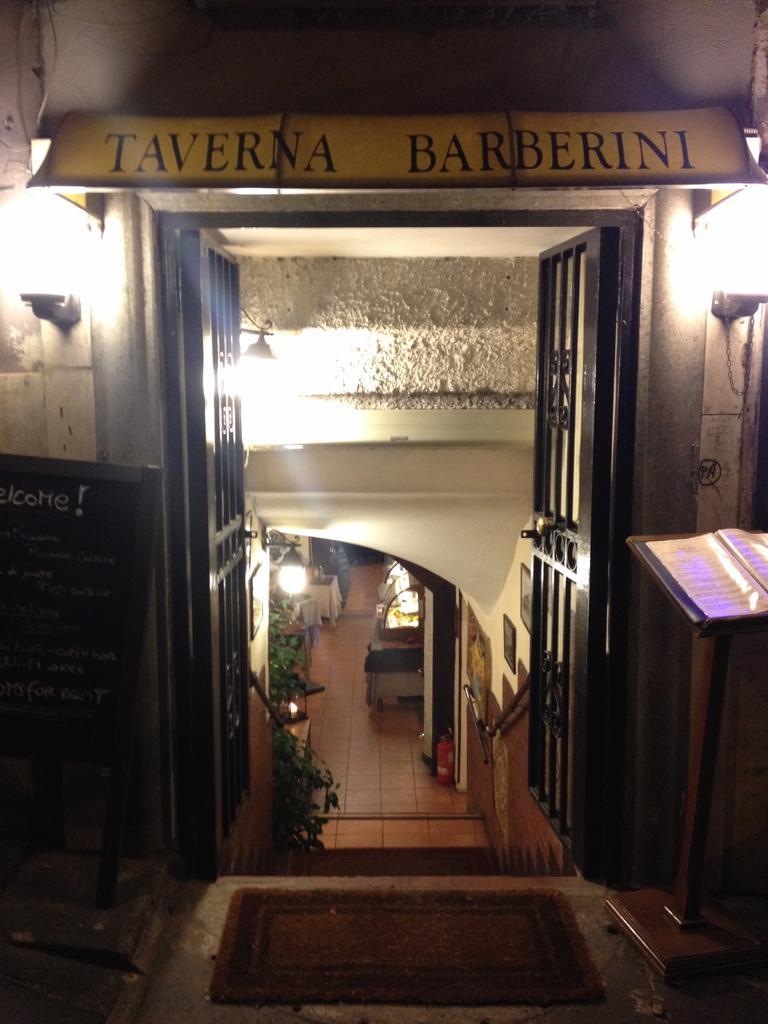Can you describe this image briefly? In this image I can see the inner part of the house. I can also see the door, few plants in green color and I can also see few lights. 